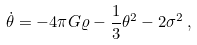Convert formula to latex. <formula><loc_0><loc_0><loc_500><loc_500>\dot { \theta } = - 4 \pi G \varrho - \frac { 1 } { 3 } \theta ^ { 2 } - 2 \sigma ^ { 2 } \, ,</formula> 